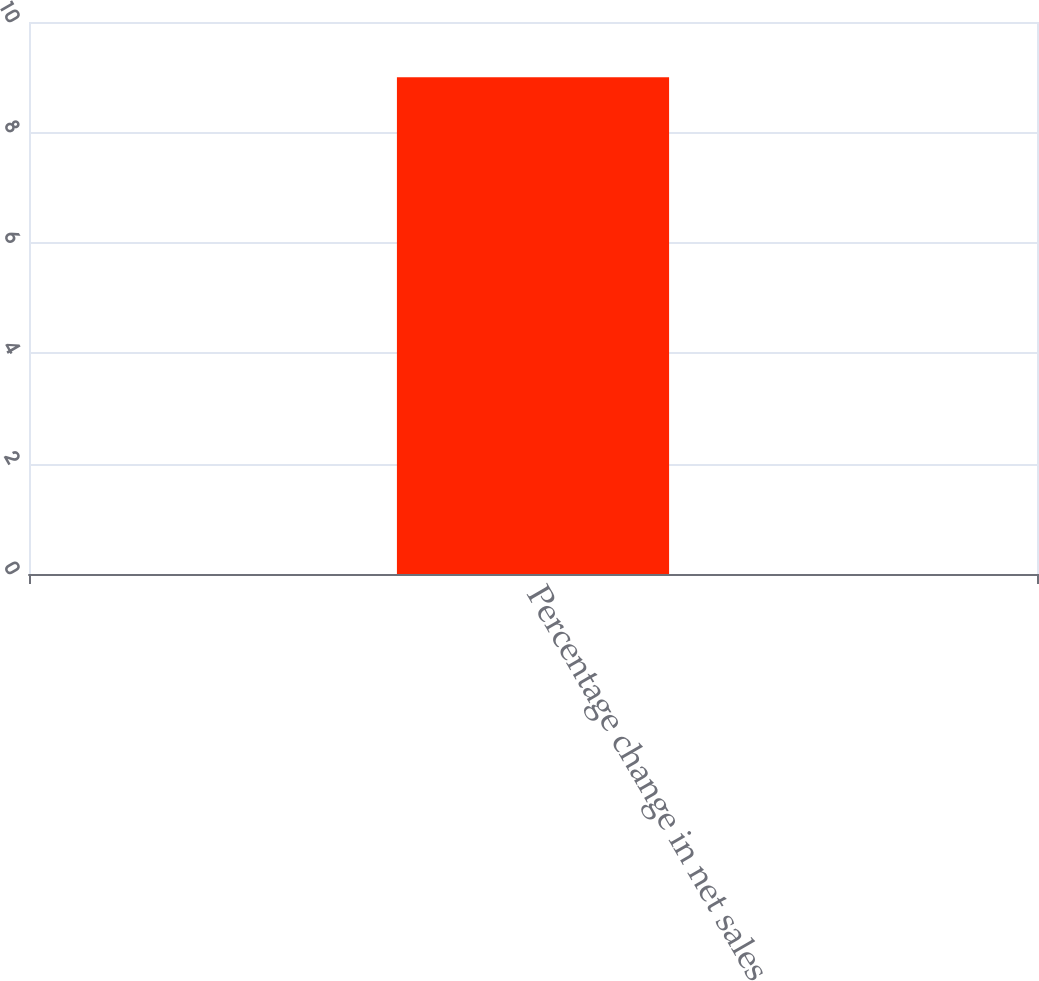Convert chart to OTSL. <chart><loc_0><loc_0><loc_500><loc_500><bar_chart><fcel>Percentage change in net sales<nl><fcel>9<nl></chart> 